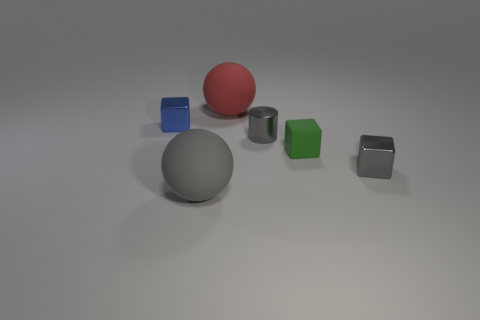What number of metal cubes are to the right of the metal cube that is behind the green thing?
Offer a very short reply. 1. What number of big red rubber objects are in front of the big red rubber object?
Offer a very short reply. 0. How many other things are the same size as the blue cube?
Your answer should be very brief. 3. There is another object that is the same shape as the red object; what is its size?
Provide a short and direct response. Large. There is a tiny gray thing behind the small matte object; what shape is it?
Offer a very short reply. Cylinder. There is a big matte ball on the right side of the rubber sphere that is in front of the red rubber ball; what is its color?
Ensure brevity in your answer.  Red. What number of things are small gray shiny things that are to the left of the green rubber thing or metal cubes?
Your response must be concise. 3. Is the size of the red thing the same as the shiny block in front of the blue object?
Give a very brief answer. No. How many large objects are gray cubes or gray metallic cylinders?
Your response must be concise. 0. What shape is the big red thing?
Keep it short and to the point. Sphere. 